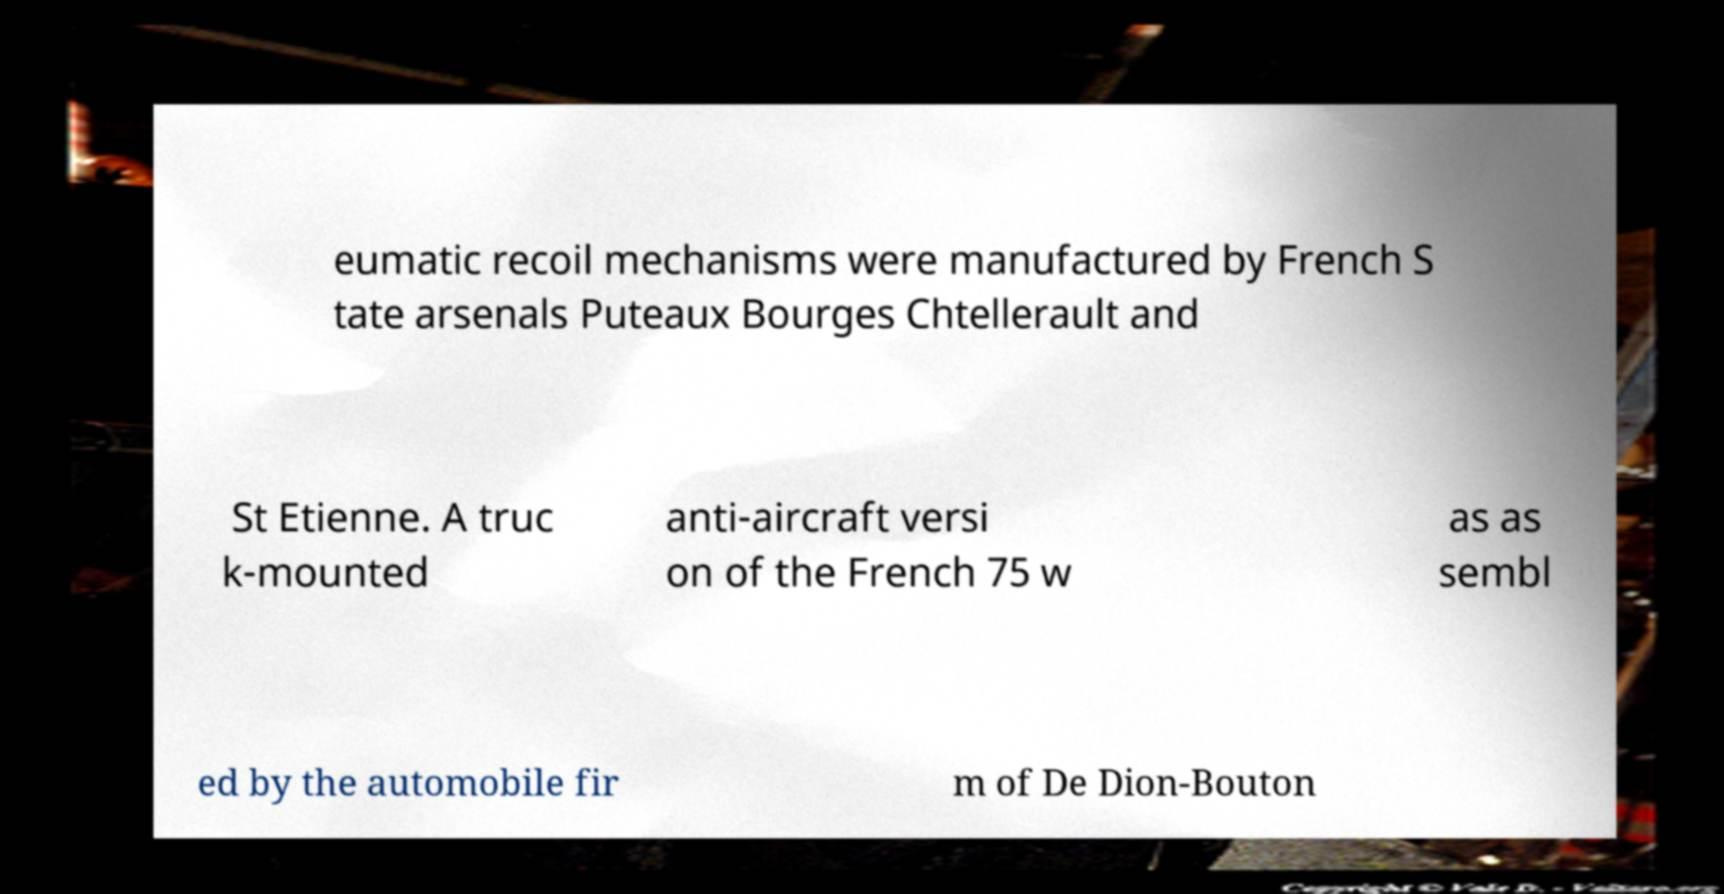Please read and relay the text visible in this image. What does it say? eumatic recoil mechanisms were manufactured by French S tate arsenals Puteaux Bourges Chtellerault and St Etienne. A truc k-mounted anti-aircraft versi on of the French 75 w as as sembl ed by the automobile fir m of De Dion-Bouton 